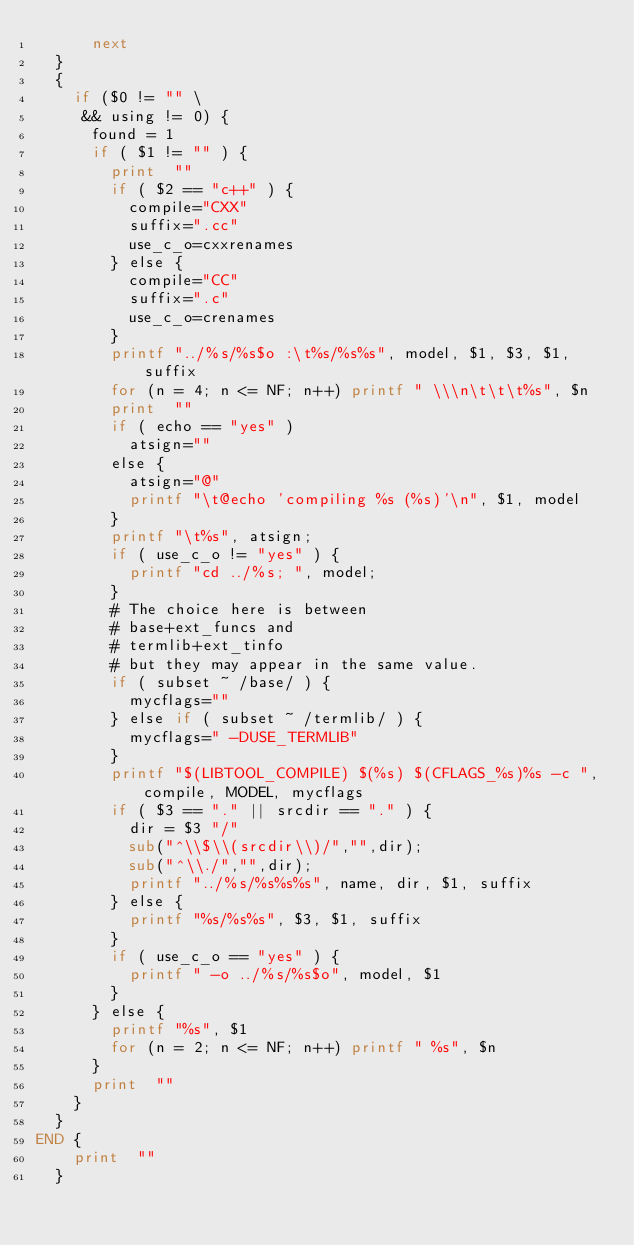Convert code to text. <code><loc_0><loc_0><loc_500><loc_500><_Awk_>			next
	}
	{
		if ($0 != "" \
		 && using != 0) {
			found = 1
			if ( $1 != "" ) {
				print  ""
				if ( $2 == "c++" ) {
					compile="CXX"
					suffix=".cc"
					use_c_o=cxxrenames
				} else {
					compile="CC"
					suffix=".c"
					use_c_o=crenames
				}
				printf "../%s/%s$o :\t%s/%s%s", model, $1, $3, $1, suffix
				for (n = 4; n <= NF; n++) printf " \\\n\t\t\t%s", $n
				print  ""
				if ( echo == "yes" )
					atsign=""
				else {
					atsign="@"
					printf "\t@echo 'compiling %s (%s)'\n", $1, model
				}
				printf "\t%s", atsign;
				if ( use_c_o != "yes" ) {
					printf "cd ../%s; ", model;
				}
				# The choice here is between
				#	base+ext_funcs and
				#	termlib+ext_tinfo
				# but they may appear in the same value.
				if ( subset ~ /base/ ) {
					mycflags=""
				} else if ( subset ~ /termlib/ ) {
					mycflags=" -DUSE_TERMLIB"
				}
				printf "$(LIBTOOL_COMPILE) $(%s) $(CFLAGS_%s)%s -c ", compile, MODEL, mycflags
				if ( $3 == "." || srcdir == "." ) {
					dir = $3 "/"
					sub("^\\$\\(srcdir\\)/","",dir);
					sub("^\\./","",dir);
					printf "../%s/%s%s%s", name, dir, $1, suffix
				} else {
					printf "%s/%s%s", $3, $1, suffix
				}
				if ( use_c_o == "yes" ) {
					printf " -o ../%s/%s$o", model, $1
				}
			} else {
				printf "%s", $1
				for (n = 2; n <= NF; n++) printf " %s", $n
			}
			print  ""
		}
	}
END	{
		print  ""
	}
</code> 